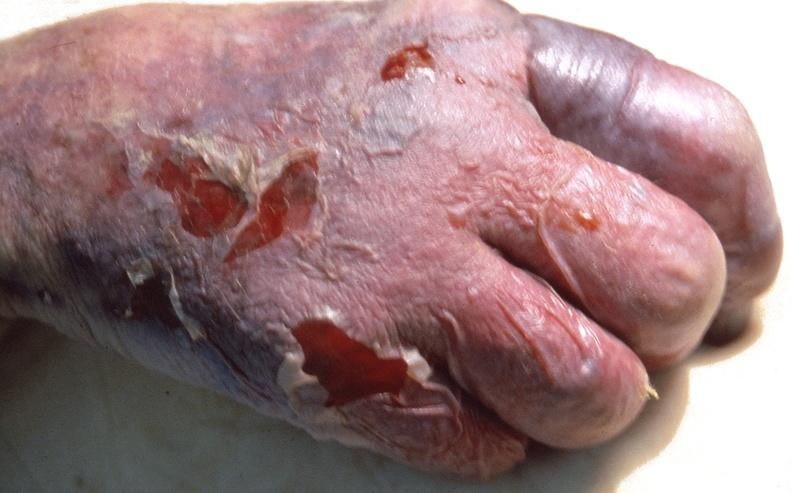does neuronophagia show skin ulceration and necrosis, disseminated intravascular coagulation due to acetaminophen toxicity?
Answer the question using a single word or phrase. No 